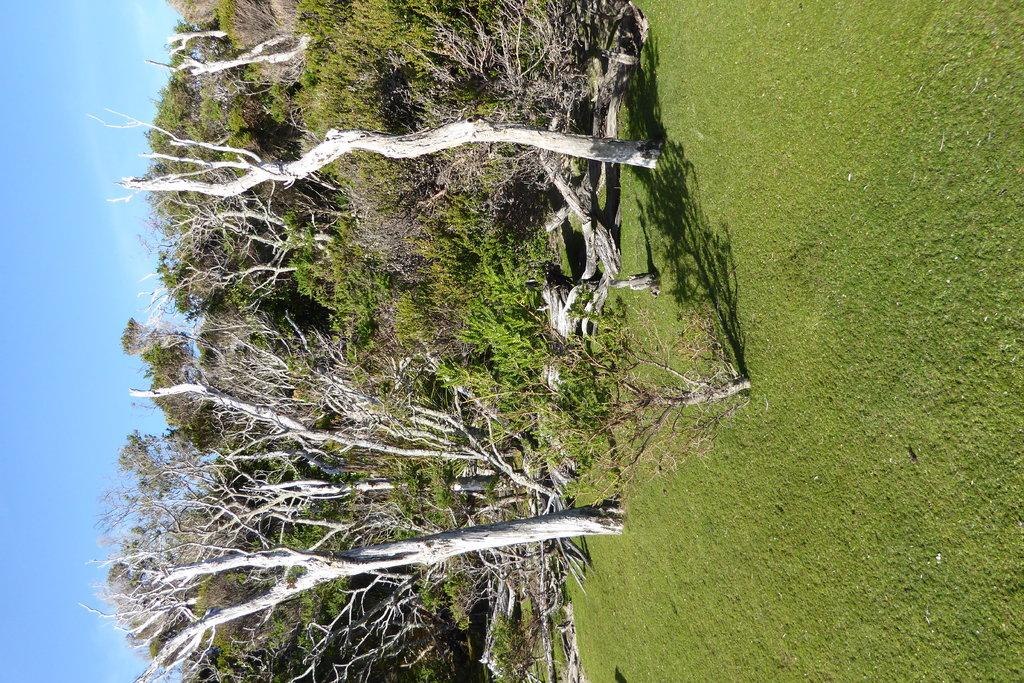What is located in the center of the image? There are trees in the center of the image. What type of vegetation is at the bottom of the image? There is grass at the bottom of the image. What is visible at the top of the image? The sky is visible at the top of the image. How many grapes are hanging from the trees in the image? There are no grapes present in the image; it features trees and grass. What type of pollution can be seen in the image? There is no pollution visible in the image; it is a natural scene with trees, grass, and sky. 